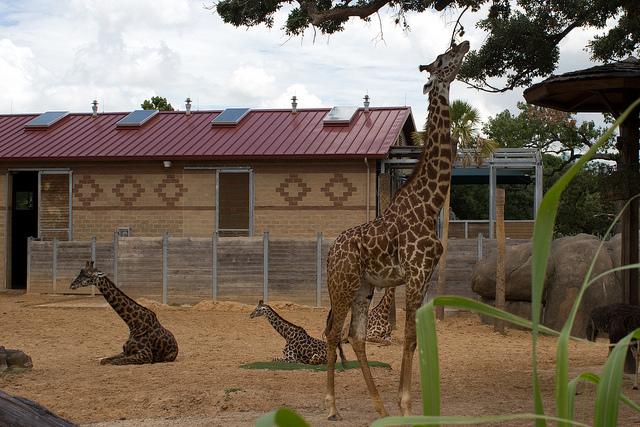Is there a bench in front of the fence?
Keep it brief. No. Is the wood painted?
Short answer required. No. Is this animal in its natural habitat?
Be succinct. No. Are there many plants?
Be succinct. Yes. How many giraffes are sitting?
Keep it brief. 3. Is the older giraffe standing up straight?
Be succinct. Yes. What is the fence made out of?
Quick response, please. Wood. Where is the lion?
Give a very brief answer. Not there. Are some of the giraffes resting?
Concise answer only. Yes. Can you see shadow in this picture?
Write a very short answer. No. Is a shadow cast?
Give a very brief answer. No. What material is the roof comprised of?
Answer briefly. Metal. Is the farm fertile?
Short answer required. No. Do you think these giraffes are free to roam?
Concise answer only. No. How many baby giraffes are pictured?
Concise answer only. 2. What color is the house?
Keep it brief. Brown. How many animals in this photo?
Concise answer only. 4. Is this a dairy farm?
Keep it brief. No. What are the animals sitting under?
Answer briefly. Tree. How hard is it to tell where one giraffe's body ends and the other begins?
Quick response, please. Not hard. How is the baby giraffe standing?
Keep it brief. Sitting. What baby animal is in the photo?
Be succinct. Giraffe. Is the sun shining on the treetops?
Keep it brief. Yes. How many children are in the picture?
Write a very short answer. 0. How many giraffes are there?
Concise answer only. 4. Are the animals hungry?
Short answer required. Yes. What kind of business is this?
Write a very short answer. Zoo. Is this a garden?
Short answer required. No. Are these two giraffes a couple?
Quick response, please. No. What is the fence made of?
Quick response, please. Wood. What color is the trim on the building?
Quick response, please. Brown. What are these animals?
Answer briefly. Giraffes. What is that thing leaning against the house in the background?
Write a very short answer. Fence. What shapes are on the wall?
Give a very brief answer. Diamonds. How many animals are there?
Concise answer only. 3. What color are the animals?
Write a very short answer. Brown. Is the giraffe bending over a fence?
Give a very brief answer. No. What is between the two giraffes?
Concise answer only. Dirt. How many doors make one door?
Short answer required. 1. What color is the barn?
Keep it brief. Brown. Could the giraffe touch the boy if it tried to?
Answer briefly. Yes. What time of day is it in this photo?
Concise answer only. Afternoon. How many giraffes?
Give a very brief answer. 4. How many species are in this picture?
Keep it brief. 1. Are all of these the same type of animal?
Short answer required. Yes. Which baby is smiling?
Be succinct. None. What animal is there?
Be succinct. Giraffe. What are the animals doing?
Write a very short answer. Relaxing. Are the giraffes resting their heads?
Quick response, please. No. What is on the wall of the barn?
Write a very short answer. Brick. 